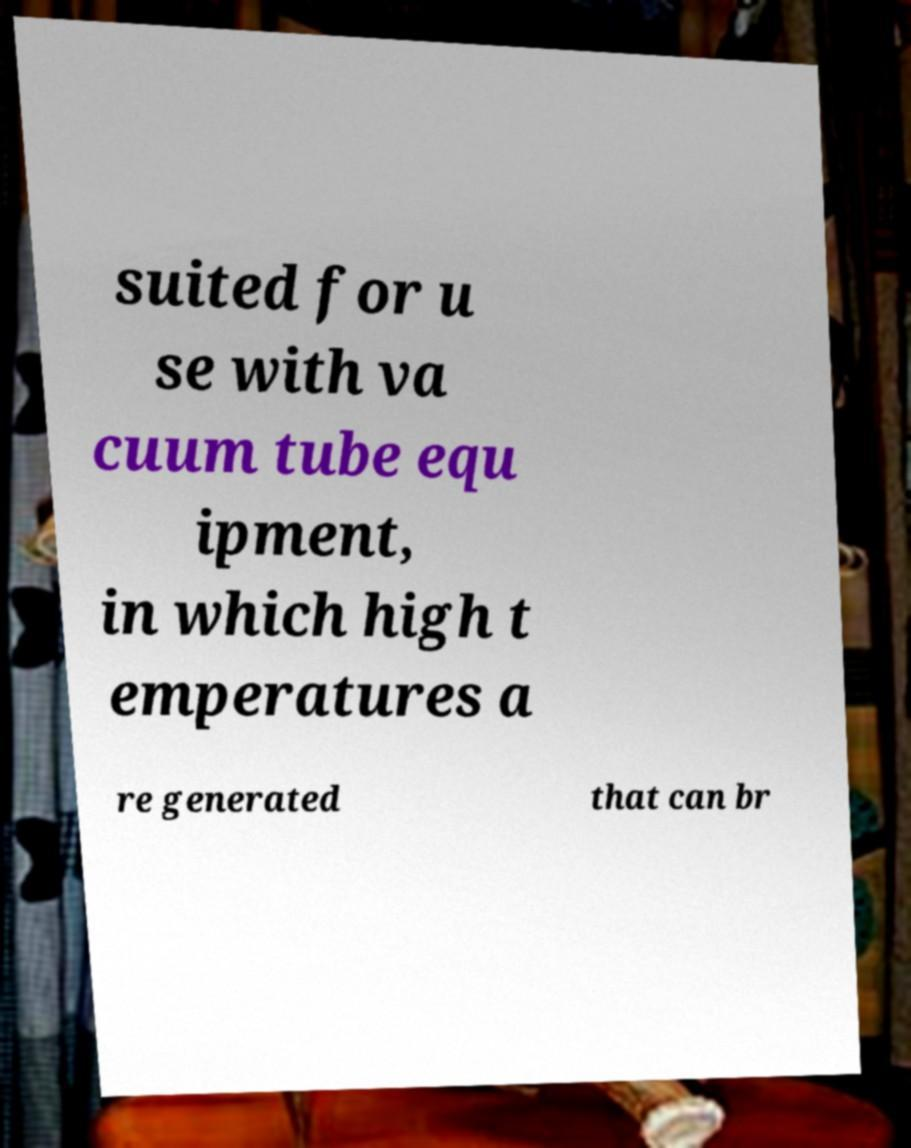Can you read and provide the text displayed in the image?This photo seems to have some interesting text. Can you extract and type it out for me? suited for u se with va cuum tube equ ipment, in which high t emperatures a re generated that can br 